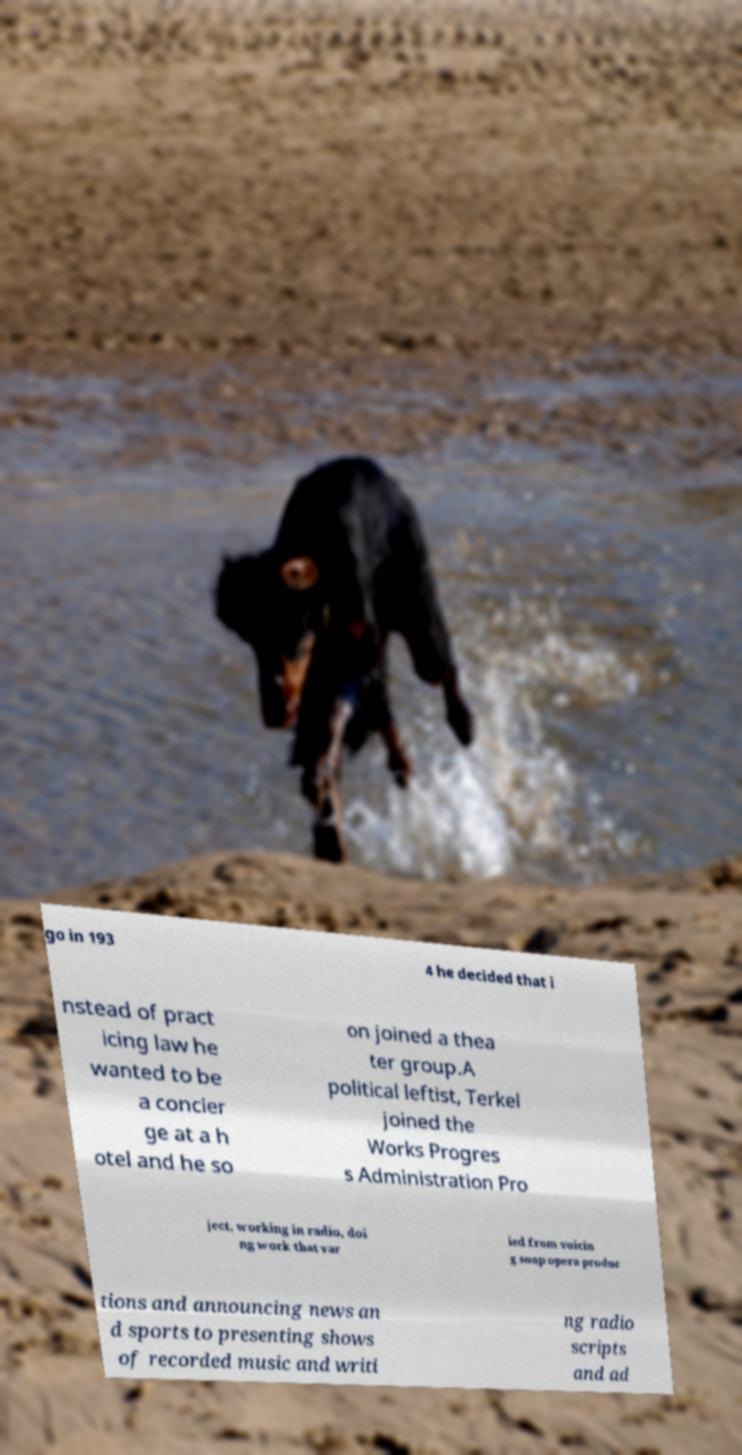I need the written content from this picture converted into text. Can you do that? go in 193 4 he decided that i nstead of pract icing law he wanted to be a concier ge at a h otel and he so on joined a thea ter group.A political leftist, Terkel joined the Works Progres s Administration Pro ject, working in radio, doi ng work that var ied from voicin g soap opera produc tions and announcing news an d sports to presenting shows of recorded music and writi ng radio scripts and ad 